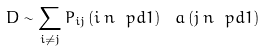<formula> <loc_0><loc_0><loc_500><loc_500>\ D \sim \sum _ { i \neq j } P _ { i j } \, ( i \, n \ p d 1 ) \, \ a \, ( j \, n \ p d 1 )</formula> 